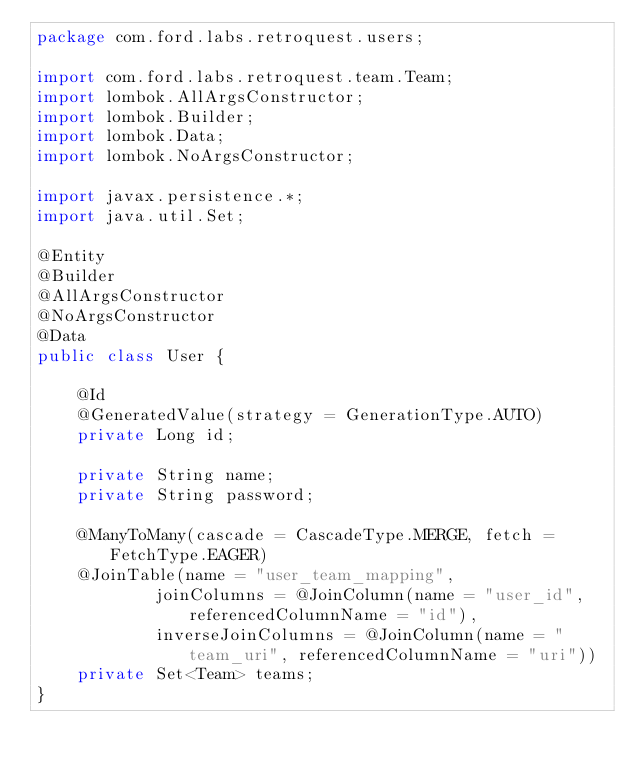Convert code to text. <code><loc_0><loc_0><loc_500><loc_500><_Java_>package com.ford.labs.retroquest.users;

import com.ford.labs.retroquest.team.Team;
import lombok.AllArgsConstructor;
import lombok.Builder;
import lombok.Data;
import lombok.NoArgsConstructor;

import javax.persistence.*;
import java.util.Set;

@Entity
@Builder
@AllArgsConstructor
@NoArgsConstructor
@Data
public class User {

    @Id
    @GeneratedValue(strategy = GenerationType.AUTO)
    private Long id;

    private String name;
    private String password;

    @ManyToMany(cascade = CascadeType.MERGE, fetch = FetchType.EAGER)
    @JoinTable(name = "user_team_mapping",
            joinColumns = @JoinColumn(name = "user_id", referencedColumnName = "id"),
            inverseJoinColumns = @JoinColumn(name = "team_uri", referencedColumnName = "uri"))
    private Set<Team> teams;
}
</code> 